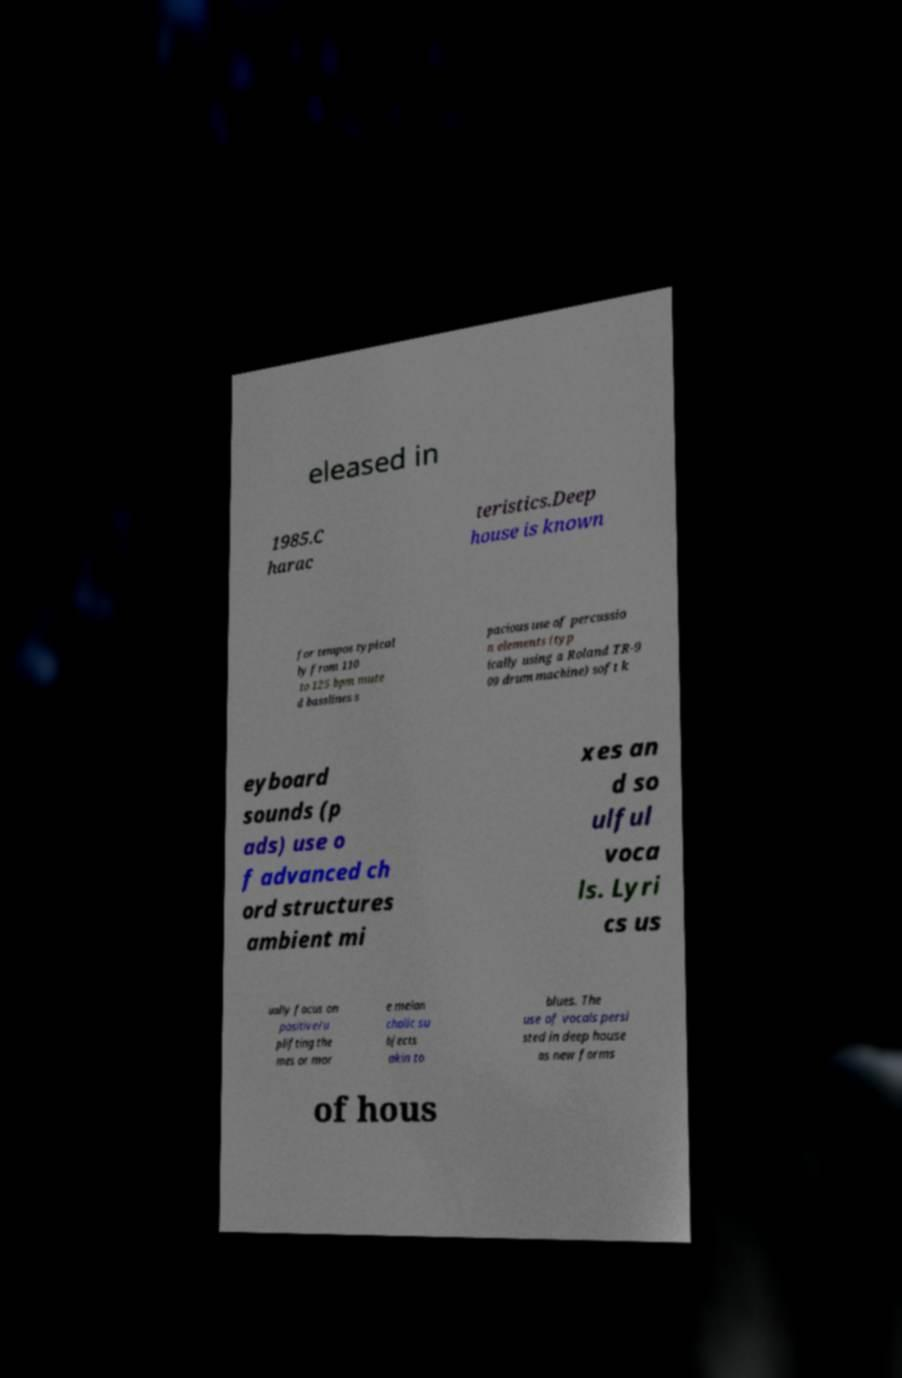There's text embedded in this image that I need extracted. Can you transcribe it verbatim? eleased in 1985.C harac teristics.Deep house is known for tempos typical ly from 110 to 125 bpm mute d basslines s pacious use of percussio n elements (typ ically using a Roland TR-9 09 drum machine) soft k eyboard sounds (p ads) use o f advanced ch ord structures ambient mi xes an d so ulful voca ls. Lyri cs us ually focus on positive/u plifting the mes or mor e melan cholic su bjects akin to blues. The use of vocals persi sted in deep house as new forms of hous 